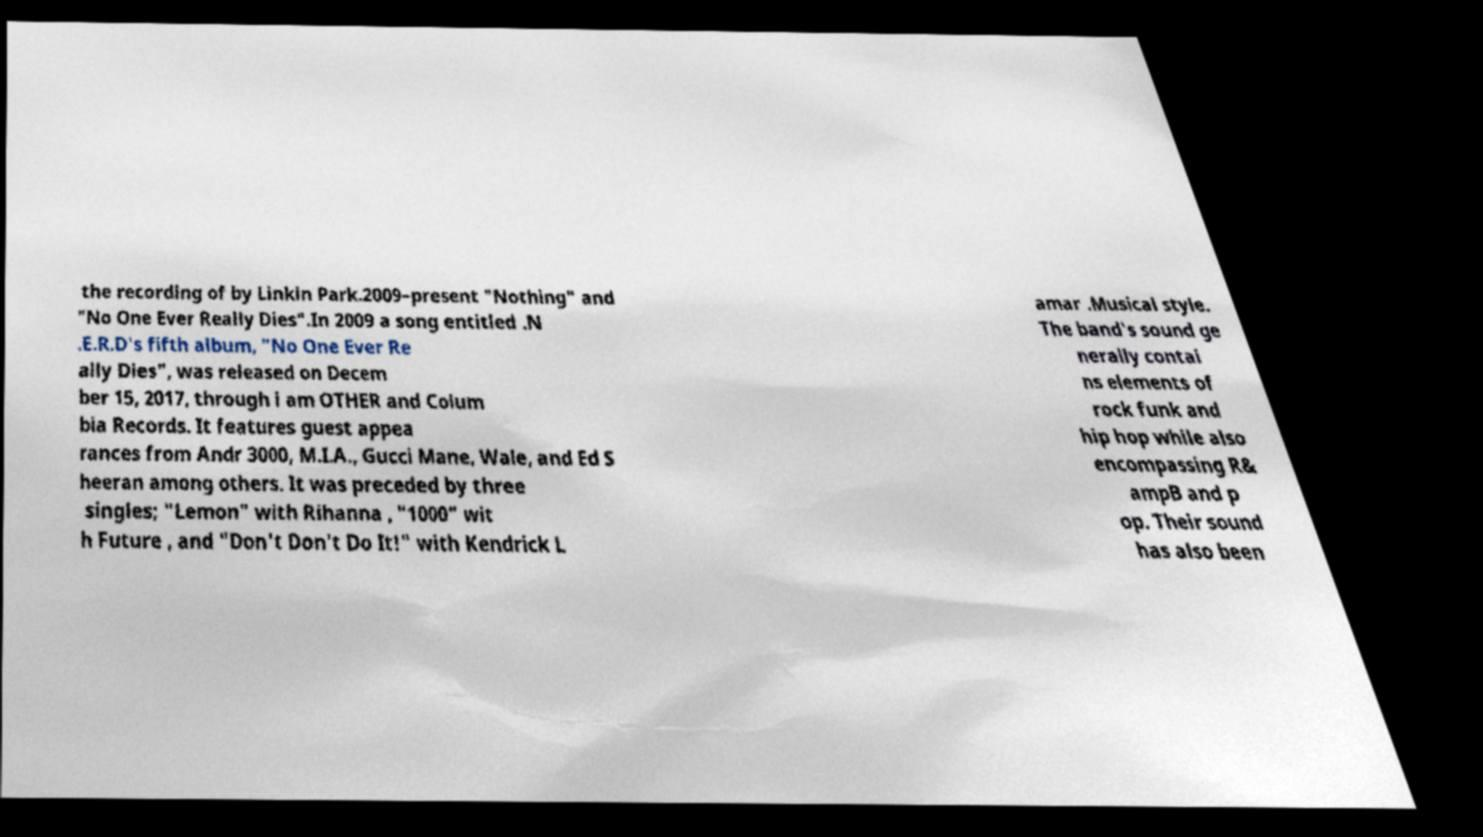Can you accurately transcribe the text from the provided image for me? the recording of by Linkin Park.2009–present "Nothing" and "No One Ever Really Dies".In 2009 a song entitled .N .E.R.D's fifth album, "No One Ever Re ally Dies", was released on Decem ber 15, 2017, through i am OTHER and Colum bia Records. It features guest appea rances from Andr 3000, M.I.A., Gucci Mane, Wale, and Ed S heeran among others. It was preceded by three singles; "Lemon" with Rihanna , "1000" wit h Future , and "Don't Don't Do It!" with Kendrick L amar .Musical style. The band's sound ge nerally contai ns elements of rock funk and hip hop while also encompassing R& ampB and p op. Their sound has also been 